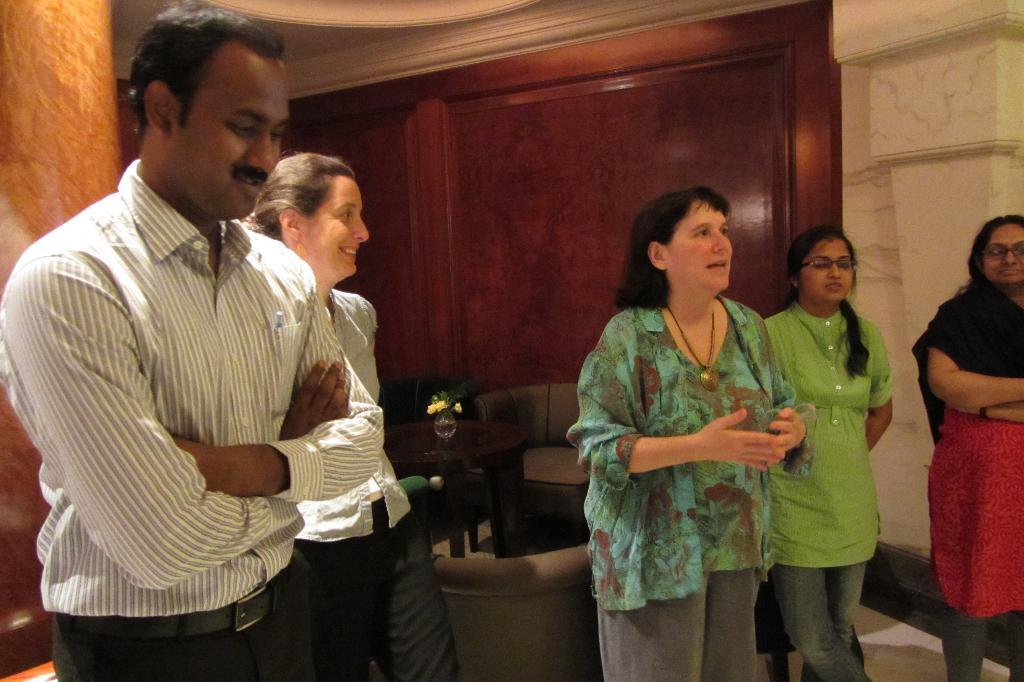How many people are on the floor in the image? There are five persons on the floor in the image. What type of furniture is present in the image? There are sofas and a table in the image. What decorative item can be seen on the table? There is a flower vase in the image. What is visible in the background of the image? There is a wall in the background of the image. What type of baseball is being played in the image? There is no baseball or any indication of a game being played in the image. 